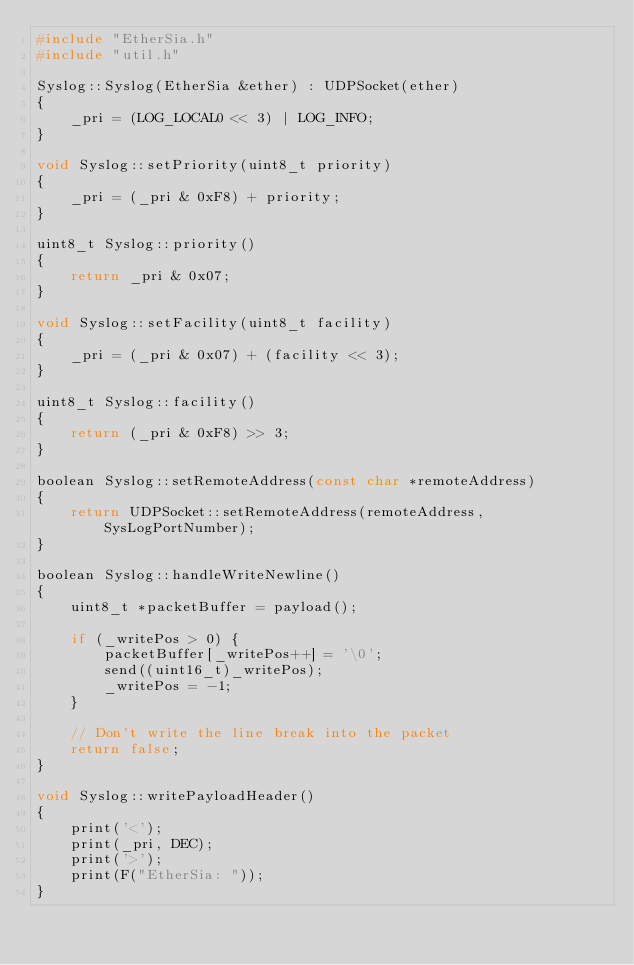Convert code to text. <code><loc_0><loc_0><loc_500><loc_500><_C++_>#include "EtherSia.h"
#include "util.h"

Syslog::Syslog(EtherSia &ether) : UDPSocket(ether)
{
    _pri = (LOG_LOCAL0 << 3) | LOG_INFO;
}

void Syslog::setPriority(uint8_t priority)
{
    _pri = (_pri & 0xF8) + priority;
}

uint8_t Syslog::priority()
{
    return _pri & 0x07;
}

void Syslog::setFacility(uint8_t facility)
{
    _pri = (_pri & 0x07) + (facility << 3);
}

uint8_t Syslog::facility()
{
    return (_pri & 0xF8) >> 3;
}

boolean Syslog::setRemoteAddress(const char *remoteAddress)
{
    return UDPSocket::setRemoteAddress(remoteAddress, SysLogPortNumber);
}

boolean Syslog::handleWriteNewline()
{
    uint8_t *packetBuffer = payload();

    if (_writePos > 0) {
        packetBuffer[_writePos++] = '\0';
        send((uint16_t)_writePos);
        _writePos = -1;
    }

    // Don't write the line break into the packet
    return false;
}

void Syslog::writePayloadHeader()
{
    print('<');
    print(_pri, DEC);
    print('>');
    print(F("EtherSia: "));
}
</code> 